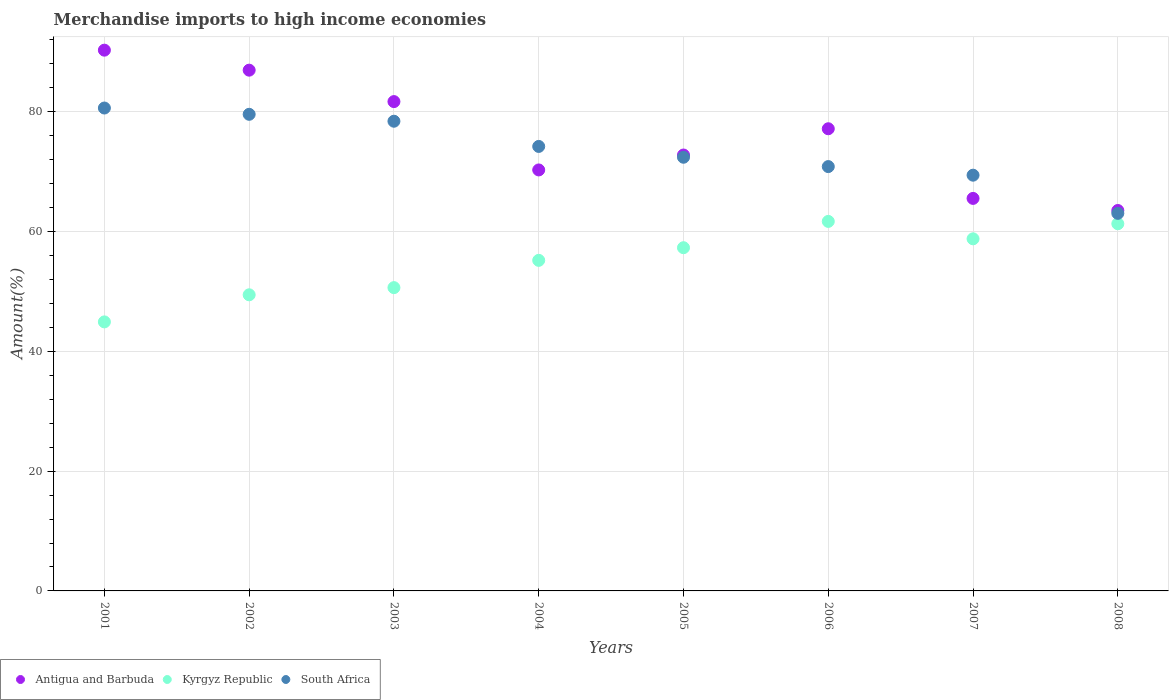What is the percentage of amount earned from merchandise imports in Kyrgyz Republic in 2001?
Keep it short and to the point. 44.92. Across all years, what is the maximum percentage of amount earned from merchandise imports in South Africa?
Make the answer very short. 80.63. Across all years, what is the minimum percentage of amount earned from merchandise imports in South Africa?
Provide a short and direct response. 63.05. In which year was the percentage of amount earned from merchandise imports in South Africa maximum?
Offer a terse response. 2001. What is the total percentage of amount earned from merchandise imports in Kyrgyz Republic in the graph?
Keep it short and to the point. 439.32. What is the difference between the percentage of amount earned from merchandise imports in South Africa in 2001 and that in 2007?
Your answer should be compact. 11.21. What is the difference between the percentage of amount earned from merchandise imports in Kyrgyz Republic in 2004 and the percentage of amount earned from merchandise imports in South Africa in 2003?
Keep it short and to the point. -23.23. What is the average percentage of amount earned from merchandise imports in Kyrgyz Republic per year?
Keep it short and to the point. 54.92. In the year 2003, what is the difference between the percentage of amount earned from merchandise imports in Kyrgyz Republic and percentage of amount earned from merchandise imports in Antigua and Barbuda?
Your answer should be very brief. -31.06. What is the ratio of the percentage of amount earned from merchandise imports in Kyrgyz Republic in 2003 to that in 2006?
Offer a very short reply. 0.82. Is the percentage of amount earned from merchandise imports in Kyrgyz Republic in 2002 less than that in 2003?
Provide a succinct answer. Yes. Is the difference between the percentage of amount earned from merchandise imports in Kyrgyz Republic in 2004 and 2008 greater than the difference between the percentage of amount earned from merchandise imports in Antigua and Barbuda in 2004 and 2008?
Provide a succinct answer. No. What is the difference between the highest and the second highest percentage of amount earned from merchandise imports in Antigua and Barbuda?
Your response must be concise. 3.34. What is the difference between the highest and the lowest percentage of amount earned from merchandise imports in Kyrgyz Republic?
Offer a very short reply. 16.78. Is the sum of the percentage of amount earned from merchandise imports in South Africa in 2002 and 2008 greater than the maximum percentage of amount earned from merchandise imports in Kyrgyz Republic across all years?
Give a very brief answer. Yes. Does the percentage of amount earned from merchandise imports in Antigua and Barbuda monotonically increase over the years?
Your response must be concise. No. How many dotlines are there?
Offer a very short reply. 3. What is the difference between two consecutive major ticks on the Y-axis?
Offer a terse response. 20. Are the values on the major ticks of Y-axis written in scientific E-notation?
Offer a very short reply. No. Does the graph contain any zero values?
Provide a short and direct response. No. How many legend labels are there?
Make the answer very short. 3. How are the legend labels stacked?
Ensure brevity in your answer.  Horizontal. What is the title of the graph?
Offer a terse response. Merchandise imports to high income economies. What is the label or title of the Y-axis?
Ensure brevity in your answer.  Amount(%). What is the Amount(%) of Antigua and Barbuda in 2001?
Your response must be concise. 90.29. What is the Amount(%) of Kyrgyz Republic in 2001?
Your answer should be compact. 44.92. What is the Amount(%) in South Africa in 2001?
Make the answer very short. 80.63. What is the Amount(%) of Antigua and Barbuda in 2002?
Provide a succinct answer. 86.95. What is the Amount(%) in Kyrgyz Republic in 2002?
Offer a very short reply. 49.44. What is the Amount(%) in South Africa in 2002?
Make the answer very short. 79.58. What is the Amount(%) of Antigua and Barbuda in 2003?
Ensure brevity in your answer.  81.71. What is the Amount(%) in Kyrgyz Republic in 2003?
Keep it short and to the point. 50.64. What is the Amount(%) in South Africa in 2003?
Keep it short and to the point. 78.43. What is the Amount(%) in Antigua and Barbuda in 2004?
Keep it short and to the point. 70.29. What is the Amount(%) of Kyrgyz Republic in 2004?
Offer a terse response. 55.2. What is the Amount(%) of South Africa in 2004?
Ensure brevity in your answer.  74.22. What is the Amount(%) of Antigua and Barbuda in 2005?
Ensure brevity in your answer.  72.79. What is the Amount(%) in Kyrgyz Republic in 2005?
Your answer should be compact. 57.31. What is the Amount(%) of South Africa in 2005?
Offer a terse response. 72.41. What is the Amount(%) in Antigua and Barbuda in 2006?
Your answer should be compact. 77.17. What is the Amount(%) of Kyrgyz Republic in 2006?
Your answer should be very brief. 61.7. What is the Amount(%) in South Africa in 2006?
Keep it short and to the point. 70.85. What is the Amount(%) in Antigua and Barbuda in 2007?
Give a very brief answer. 65.54. What is the Amount(%) in Kyrgyz Republic in 2007?
Provide a succinct answer. 58.79. What is the Amount(%) of South Africa in 2007?
Ensure brevity in your answer.  69.42. What is the Amount(%) of Antigua and Barbuda in 2008?
Offer a very short reply. 63.52. What is the Amount(%) in Kyrgyz Republic in 2008?
Your response must be concise. 61.31. What is the Amount(%) of South Africa in 2008?
Your answer should be compact. 63.05. Across all years, what is the maximum Amount(%) in Antigua and Barbuda?
Make the answer very short. 90.29. Across all years, what is the maximum Amount(%) of Kyrgyz Republic?
Your answer should be very brief. 61.7. Across all years, what is the maximum Amount(%) in South Africa?
Your answer should be compact. 80.63. Across all years, what is the minimum Amount(%) of Antigua and Barbuda?
Ensure brevity in your answer.  63.52. Across all years, what is the minimum Amount(%) of Kyrgyz Republic?
Your answer should be compact. 44.92. Across all years, what is the minimum Amount(%) in South Africa?
Make the answer very short. 63.05. What is the total Amount(%) of Antigua and Barbuda in the graph?
Your answer should be compact. 608.27. What is the total Amount(%) in Kyrgyz Republic in the graph?
Give a very brief answer. 439.32. What is the total Amount(%) in South Africa in the graph?
Provide a short and direct response. 588.6. What is the difference between the Amount(%) of Antigua and Barbuda in 2001 and that in 2002?
Make the answer very short. 3.34. What is the difference between the Amount(%) in Kyrgyz Republic in 2001 and that in 2002?
Offer a terse response. -4.52. What is the difference between the Amount(%) of South Africa in 2001 and that in 2002?
Give a very brief answer. 1.05. What is the difference between the Amount(%) of Antigua and Barbuda in 2001 and that in 2003?
Provide a succinct answer. 8.59. What is the difference between the Amount(%) of Kyrgyz Republic in 2001 and that in 2003?
Keep it short and to the point. -5.72. What is the difference between the Amount(%) of South Africa in 2001 and that in 2003?
Provide a succinct answer. 2.2. What is the difference between the Amount(%) in Antigua and Barbuda in 2001 and that in 2004?
Your response must be concise. 20. What is the difference between the Amount(%) of Kyrgyz Republic in 2001 and that in 2004?
Provide a short and direct response. -10.28. What is the difference between the Amount(%) in South Africa in 2001 and that in 2004?
Offer a terse response. 6.41. What is the difference between the Amount(%) of Antigua and Barbuda in 2001 and that in 2005?
Keep it short and to the point. 17.51. What is the difference between the Amount(%) in Kyrgyz Republic in 2001 and that in 2005?
Your answer should be compact. -12.39. What is the difference between the Amount(%) in South Africa in 2001 and that in 2005?
Make the answer very short. 8.22. What is the difference between the Amount(%) in Antigua and Barbuda in 2001 and that in 2006?
Offer a terse response. 13.12. What is the difference between the Amount(%) in Kyrgyz Republic in 2001 and that in 2006?
Provide a succinct answer. -16.78. What is the difference between the Amount(%) of South Africa in 2001 and that in 2006?
Your response must be concise. 9.78. What is the difference between the Amount(%) of Antigua and Barbuda in 2001 and that in 2007?
Your response must be concise. 24.75. What is the difference between the Amount(%) of Kyrgyz Republic in 2001 and that in 2007?
Give a very brief answer. -13.87. What is the difference between the Amount(%) of South Africa in 2001 and that in 2007?
Give a very brief answer. 11.21. What is the difference between the Amount(%) of Antigua and Barbuda in 2001 and that in 2008?
Give a very brief answer. 26.77. What is the difference between the Amount(%) in Kyrgyz Republic in 2001 and that in 2008?
Provide a succinct answer. -16.39. What is the difference between the Amount(%) in South Africa in 2001 and that in 2008?
Offer a terse response. 17.59. What is the difference between the Amount(%) of Antigua and Barbuda in 2002 and that in 2003?
Your answer should be very brief. 5.25. What is the difference between the Amount(%) of Kyrgyz Republic in 2002 and that in 2003?
Offer a very short reply. -1.2. What is the difference between the Amount(%) of South Africa in 2002 and that in 2003?
Provide a succinct answer. 1.16. What is the difference between the Amount(%) of Antigua and Barbuda in 2002 and that in 2004?
Your answer should be compact. 16.66. What is the difference between the Amount(%) in Kyrgyz Republic in 2002 and that in 2004?
Provide a succinct answer. -5.75. What is the difference between the Amount(%) in South Africa in 2002 and that in 2004?
Your answer should be compact. 5.36. What is the difference between the Amount(%) of Antigua and Barbuda in 2002 and that in 2005?
Your response must be concise. 14.17. What is the difference between the Amount(%) of Kyrgyz Republic in 2002 and that in 2005?
Your response must be concise. -7.86. What is the difference between the Amount(%) in South Africa in 2002 and that in 2005?
Make the answer very short. 7.17. What is the difference between the Amount(%) of Antigua and Barbuda in 2002 and that in 2006?
Make the answer very short. 9.78. What is the difference between the Amount(%) of Kyrgyz Republic in 2002 and that in 2006?
Make the answer very short. -12.26. What is the difference between the Amount(%) of South Africa in 2002 and that in 2006?
Your response must be concise. 8.73. What is the difference between the Amount(%) of Antigua and Barbuda in 2002 and that in 2007?
Offer a very short reply. 21.41. What is the difference between the Amount(%) in Kyrgyz Republic in 2002 and that in 2007?
Offer a terse response. -9.35. What is the difference between the Amount(%) in South Africa in 2002 and that in 2007?
Keep it short and to the point. 10.16. What is the difference between the Amount(%) of Antigua and Barbuda in 2002 and that in 2008?
Offer a terse response. 23.43. What is the difference between the Amount(%) in Kyrgyz Republic in 2002 and that in 2008?
Provide a short and direct response. -11.87. What is the difference between the Amount(%) of South Africa in 2002 and that in 2008?
Your answer should be compact. 16.54. What is the difference between the Amount(%) in Antigua and Barbuda in 2003 and that in 2004?
Give a very brief answer. 11.41. What is the difference between the Amount(%) in Kyrgyz Republic in 2003 and that in 2004?
Your answer should be very brief. -4.56. What is the difference between the Amount(%) in South Africa in 2003 and that in 2004?
Offer a terse response. 4.21. What is the difference between the Amount(%) of Antigua and Barbuda in 2003 and that in 2005?
Provide a short and direct response. 8.92. What is the difference between the Amount(%) in Kyrgyz Republic in 2003 and that in 2005?
Give a very brief answer. -6.67. What is the difference between the Amount(%) of South Africa in 2003 and that in 2005?
Keep it short and to the point. 6.01. What is the difference between the Amount(%) of Antigua and Barbuda in 2003 and that in 2006?
Provide a short and direct response. 4.54. What is the difference between the Amount(%) of Kyrgyz Republic in 2003 and that in 2006?
Your answer should be very brief. -11.06. What is the difference between the Amount(%) in South Africa in 2003 and that in 2006?
Your answer should be compact. 7.57. What is the difference between the Amount(%) in Antigua and Barbuda in 2003 and that in 2007?
Ensure brevity in your answer.  16.16. What is the difference between the Amount(%) in Kyrgyz Republic in 2003 and that in 2007?
Provide a succinct answer. -8.15. What is the difference between the Amount(%) in South Africa in 2003 and that in 2007?
Your answer should be compact. 9.01. What is the difference between the Amount(%) in Antigua and Barbuda in 2003 and that in 2008?
Offer a very short reply. 18.18. What is the difference between the Amount(%) in Kyrgyz Republic in 2003 and that in 2008?
Make the answer very short. -10.67. What is the difference between the Amount(%) of South Africa in 2003 and that in 2008?
Your answer should be very brief. 15.38. What is the difference between the Amount(%) in Antigua and Barbuda in 2004 and that in 2005?
Your answer should be very brief. -2.49. What is the difference between the Amount(%) of Kyrgyz Republic in 2004 and that in 2005?
Offer a very short reply. -2.11. What is the difference between the Amount(%) in South Africa in 2004 and that in 2005?
Offer a terse response. 1.81. What is the difference between the Amount(%) in Antigua and Barbuda in 2004 and that in 2006?
Your response must be concise. -6.88. What is the difference between the Amount(%) of Kyrgyz Republic in 2004 and that in 2006?
Keep it short and to the point. -6.5. What is the difference between the Amount(%) in South Africa in 2004 and that in 2006?
Your answer should be very brief. 3.36. What is the difference between the Amount(%) in Antigua and Barbuda in 2004 and that in 2007?
Ensure brevity in your answer.  4.75. What is the difference between the Amount(%) of Kyrgyz Republic in 2004 and that in 2007?
Ensure brevity in your answer.  -3.6. What is the difference between the Amount(%) of South Africa in 2004 and that in 2007?
Your answer should be compact. 4.8. What is the difference between the Amount(%) of Antigua and Barbuda in 2004 and that in 2008?
Your answer should be very brief. 6.77. What is the difference between the Amount(%) in Kyrgyz Republic in 2004 and that in 2008?
Your answer should be very brief. -6.11. What is the difference between the Amount(%) of South Africa in 2004 and that in 2008?
Provide a short and direct response. 11.17. What is the difference between the Amount(%) in Antigua and Barbuda in 2005 and that in 2006?
Your answer should be very brief. -4.38. What is the difference between the Amount(%) of Kyrgyz Republic in 2005 and that in 2006?
Ensure brevity in your answer.  -4.39. What is the difference between the Amount(%) of South Africa in 2005 and that in 2006?
Your response must be concise. 1.56. What is the difference between the Amount(%) in Antigua and Barbuda in 2005 and that in 2007?
Offer a very short reply. 7.24. What is the difference between the Amount(%) in Kyrgyz Republic in 2005 and that in 2007?
Your answer should be compact. -1.49. What is the difference between the Amount(%) in South Africa in 2005 and that in 2007?
Give a very brief answer. 2.99. What is the difference between the Amount(%) in Antigua and Barbuda in 2005 and that in 2008?
Provide a succinct answer. 9.26. What is the difference between the Amount(%) of Kyrgyz Republic in 2005 and that in 2008?
Your response must be concise. -4. What is the difference between the Amount(%) of South Africa in 2005 and that in 2008?
Keep it short and to the point. 9.37. What is the difference between the Amount(%) in Antigua and Barbuda in 2006 and that in 2007?
Your answer should be very brief. 11.63. What is the difference between the Amount(%) in Kyrgyz Republic in 2006 and that in 2007?
Make the answer very short. 2.91. What is the difference between the Amount(%) in South Africa in 2006 and that in 2007?
Your answer should be compact. 1.44. What is the difference between the Amount(%) of Antigua and Barbuda in 2006 and that in 2008?
Offer a terse response. 13.65. What is the difference between the Amount(%) in Kyrgyz Republic in 2006 and that in 2008?
Make the answer very short. 0.39. What is the difference between the Amount(%) of South Africa in 2006 and that in 2008?
Offer a terse response. 7.81. What is the difference between the Amount(%) in Antigua and Barbuda in 2007 and that in 2008?
Your answer should be compact. 2.02. What is the difference between the Amount(%) in Kyrgyz Republic in 2007 and that in 2008?
Your response must be concise. -2.52. What is the difference between the Amount(%) in South Africa in 2007 and that in 2008?
Keep it short and to the point. 6.37. What is the difference between the Amount(%) of Antigua and Barbuda in 2001 and the Amount(%) of Kyrgyz Republic in 2002?
Keep it short and to the point. 40.85. What is the difference between the Amount(%) of Antigua and Barbuda in 2001 and the Amount(%) of South Africa in 2002?
Give a very brief answer. 10.71. What is the difference between the Amount(%) in Kyrgyz Republic in 2001 and the Amount(%) in South Africa in 2002?
Your answer should be very brief. -34.66. What is the difference between the Amount(%) of Antigua and Barbuda in 2001 and the Amount(%) of Kyrgyz Republic in 2003?
Ensure brevity in your answer.  39.65. What is the difference between the Amount(%) in Antigua and Barbuda in 2001 and the Amount(%) in South Africa in 2003?
Your response must be concise. 11.87. What is the difference between the Amount(%) of Kyrgyz Republic in 2001 and the Amount(%) of South Africa in 2003?
Your response must be concise. -33.51. What is the difference between the Amount(%) in Antigua and Barbuda in 2001 and the Amount(%) in Kyrgyz Republic in 2004?
Your answer should be compact. 35.1. What is the difference between the Amount(%) of Antigua and Barbuda in 2001 and the Amount(%) of South Africa in 2004?
Provide a short and direct response. 16.08. What is the difference between the Amount(%) of Kyrgyz Republic in 2001 and the Amount(%) of South Africa in 2004?
Offer a terse response. -29.3. What is the difference between the Amount(%) in Antigua and Barbuda in 2001 and the Amount(%) in Kyrgyz Republic in 2005?
Ensure brevity in your answer.  32.99. What is the difference between the Amount(%) in Antigua and Barbuda in 2001 and the Amount(%) in South Africa in 2005?
Provide a succinct answer. 17.88. What is the difference between the Amount(%) in Kyrgyz Republic in 2001 and the Amount(%) in South Africa in 2005?
Your response must be concise. -27.49. What is the difference between the Amount(%) of Antigua and Barbuda in 2001 and the Amount(%) of Kyrgyz Republic in 2006?
Your answer should be compact. 28.59. What is the difference between the Amount(%) in Antigua and Barbuda in 2001 and the Amount(%) in South Africa in 2006?
Provide a short and direct response. 19.44. What is the difference between the Amount(%) in Kyrgyz Republic in 2001 and the Amount(%) in South Africa in 2006?
Provide a succinct answer. -25.93. What is the difference between the Amount(%) in Antigua and Barbuda in 2001 and the Amount(%) in Kyrgyz Republic in 2007?
Ensure brevity in your answer.  31.5. What is the difference between the Amount(%) in Antigua and Barbuda in 2001 and the Amount(%) in South Africa in 2007?
Provide a short and direct response. 20.88. What is the difference between the Amount(%) in Kyrgyz Republic in 2001 and the Amount(%) in South Africa in 2007?
Your answer should be compact. -24.5. What is the difference between the Amount(%) of Antigua and Barbuda in 2001 and the Amount(%) of Kyrgyz Republic in 2008?
Give a very brief answer. 28.98. What is the difference between the Amount(%) in Antigua and Barbuda in 2001 and the Amount(%) in South Africa in 2008?
Your answer should be compact. 27.25. What is the difference between the Amount(%) of Kyrgyz Republic in 2001 and the Amount(%) of South Africa in 2008?
Your answer should be very brief. -18.12. What is the difference between the Amount(%) of Antigua and Barbuda in 2002 and the Amount(%) of Kyrgyz Republic in 2003?
Your response must be concise. 36.31. What is the difference between the Amount(%) in Antigua and Barbuda in 2002 and the Amount(%) in South Africa in 2003?
Ensure brevity in your answer.  8.53. What is the difference between the Amount(%) of Kyrgyz Republic in 2002 and the Amount(%) of South Africa in 2003?
Keep it short and to the point. -28.98. What is the difference between the Amount(%) in Antigua and Barbuda in 2002 and the Amount(%) in Kyrgyz Republic in 2004?
Provide a succinct answer. 31.76. What is the difference between the Amount(%) of Antigua and Barbuda in 2002 and the Amount(%) of South Africa in 2004?
Provide a succinct answer. 12.73. What is the difference between the Amount(%) of Kyrgyz Republic in 2002 and the Amount(%) of South Africa in 2004?
Your answer should be compact. -24.77. What is the difference between the Amount(%) in Antigua and Barbuda in 2002 and the Amount(%) in Kyrgyz Republic in 2005?
Provide a short and direct response. 29.65. What is the difference between the Amount(%) in Antigua and Barbuda in 2002 and the Amount(%) in South Africa in 2005?
Your response must be concise. 14.54. What is the difference between the Amount(%) of Kyrgyz Republic in 2002 and the Amount(%) of South Africa in 2005?
Provide a short and direct response. -22.97. What is the difference between the Amount(%) in Antigua and Barbuda in 2002 and the Amount(%) in Kyrgyz Republic in 2006?
Provide a short and direct response. 25.25. What is the difference between the Amount(%) in Antigua and Barbuda in 2002 and the Amount(%) in South Africa in 2006?
Your response must be concise. 16.1. What is the difference between the Amount(%) of Kyrgyz Republic in 2002 and the Amount(%) of South Africa in 2006?
Offer a very short reply. -21.41. What is the difference between the Amount(%) of Antigua and Barbuda in 2002 and the Amount(%) of Kyrgyz Republic in 2007?
Offer a very short reply. 28.16. What is the difference between the Amount(%) of Antigua and Barbuda in 2002 and the Amount(%) of South Africa in 2007?
Provide a succinct answer. 17.54. What is the difference between the Amount(%) of Kyrgyz Republic in 2002 and the Amount(%) of South Africa in 2007?
Offer a terse response. -19.97. What is the difference between the Amount(%) in Antigua and Barbuda in 2002 and the Amount(%) in Kyrgyz Republic in 2008?
Keep it short and to the point. 25.64. What is the difference between the Amount(%) in Antigua and Barbuda in 2002 and the Amount(%) in South Africa in 2008?
Offer a terse response. 23.91. What is the difference between the Amount(%) of Kyrgyz Republic in 2002 and the Amount(%) of South Africa in 2008?
Your response must be concise. -13.6. What is the difference between the Amount(%) of Antigua and Barbuda in 2003 and the Amount(%) of Kyrgyz Republic in 2004?
Your answer should be compact. 26.51. What is the difference between the Amount(%) of Antigua and Barbuda in 2003 and the Amount(%) of South Africa in 2004?
Provide a succinct answer. 7.49. What is the difference between the Amount(%) in Kyrgyz Republic in 2003 and the Amount(%) in South Africa in 2004?
Your answer should be very brief. -23.58. What is the difference between the Amount(%) of Antigua and Barbuda in 2003 and the Amount(%) of Kyrgyz Republic in 2005?
Make the answer very short. 24.4. What is the difference between the Amount(%) in Antigua and Barbuda in 2003 and the Amount(%) in South Africa in 2005?
Offer a very short reply. 9.29. What is the difference between the Amount(%) of Kyrgyz Republic in 2003 and the Amount(%) of South Africa in 2005?
Your response must be concise. -21.77. What is the difference between the Amount(%) in Antigua and Barbuda in 2003 and the Amount(%) in Kyrgyz Republic in 2006?
Offer a very short reply. 20.01. What is the difference between the Amount(%) in Antigua and Barbuda in 2003 and the Amount(%) in South Africa in 2006?
Your response must be concise. 10.85. What is the difference between the Amount(%) of Kyrgyz Republic in 2003 and the Amount(%) of South Africa in 2006?
Your response must be concise. -20.21. What is the difference between the Amount(%) in Antigua and Barbuda in 2003 and the Amount(%) in Kyrgyz Republic in 2007?
Ensure brevity in your answer.  22.91. What is the difference between the Amount(%) in Antigua and Barbuda in 2003 and the Amount(%) in South Africa in 2007?
Give a very brief answer. 12.29. What is the difference between the Amount(%) of Kyrgyz Republic in 2003 and the Amount(%) of South Africa in 2007?
Provide a short and direct response. -18.78. What is the difference between the Amount(%) of Antigua and Barbuda in 2003 and the Amount(%) of Kyrgyz Republic in 2008?
Give a very brief answer. 20.39. What is the difference between the Amount(%) in Antigua and Barbuda in 2003 and the Amount(%) in South Africa in 2008?
Keep it short and to the point. 18.66. What is the difference between the Amount(%) in Kyrgyz Republic in 2003 and the Amount(%) in South Africa in 2008?
Give a very brief answer. -12.4. What is the difference between the Amount(%) in Antigua and Barbuda in 2004 and the Amount(%) in Kyrgyz Republic in 2005?
Offer a terse response. 12.99. What is the difference between the Amount(%) of Antigua and Barbuda in 2004 and the Amount(%) of South Africa in 2005?
Ensure brevity in your answer.  -2.12. What is the difference between the Amount(%) of Kyrgyz Republic in 2004 and the Amount(%) of South Africa in 2005?
Provide a short and direct response. -17.21. What is the difference between the Amount(%) of Antigua and Barbuda in 2004 and the Amount(%) of Kyrgyz Republic in 2006?
Keep it short and to the point. 8.59. What is the difference between the Amount(%) of Antigua and Barbuda in 2004 and the Amount(%) of South Africa in 2006?
Your answer should be very brief. -0.56. What is the difference between the Amount(%) in Kyrgyz Republic in 2004 and the Amount(%) in South Africa in 2006?
Offer a very short reply. -15.66. What is the difference between the Amount(%) of Antigua and Barbuda in 2004 and the Amount(%) of Kyrgyz Republic in 2007?
Offer a terse response. 11.5. What is the difference between the Amount(%) in Antigua and Barbuda in 2004 and the Amount(%) in South Africa in 2007?
Your answer should be compact. 0.88. What is the difference between the Amount(%) in Kyrgyz Republic in 2004 and the Amount(%) in South Africa in 2007?
Your answer should be compact. -14.22. What is the difference between the Amount(%) in Antigua and Barbuda in 2004 and the Amount(%) in Kyrgyz Republic in 2008?
Offer a very short reply. 8.98. What is the difference between the Amount(%) of Antigua and Barbuda in 2004 and the Amount(%) of South Africa in 2008?
Keep it short and to the point. 7.25. What is the difference between the Amount(%) in Kyrgyz Republic in 2004 and the Amount(%) in South Africa in 2008?
Offer a terse response. -7.85. What is the difference between the Amount(%) of Antigua and Barbuda in 2005 and the Amount(%) of Kyrgyz Republic in 2006?
Offer a very short reply. 11.08. What is the difference between the Amount(%) in Antigua and Barbuda in 2005 and the Amount(%) in South Africa in 2006?
Ensure brevity in your answer.  1.93. What is the difference between the Amount(%) in Kyrgyz Republic in 2005 and the Amount(%) in South Africa in 2006?
Offer a very short reply. -13.55. What is the difference between the Amount(%) in Antigua and Barbuda in 2005 and the Amount(%) in Kyrgyz Republic in 2007?
Give a very brief answer. 13.99. What is the difference between the Amount(%) of Antigua and Barbuda in 2005 and the Amount(%) of South Africa in 2007?
Provide a short and direct response. 3.37. What is the difference between the Amount(%) in Kyrgyz Republic in 2005 and the Amount(%) in South Africa in 2007?
Your answer should be compact. -12.11. What is the difference between the Amount(%) in Antigua and Barbuda in 2005 and the Amount(%) in Kyrgyz Republic in 2008?
Your answer should be compact. 11.47. What is the difference between the Amount(%) in Antigua and Barbuda in 2005 and the Amount(%) in South Africa in 2008?
Make the answer very short. 9.74. What is the difference between the Amount(%) of Kyrgyz Republic in 2005 and the Amount(%) of South Africa in 2008?
Provide a short and direct response. -5.74. What is the difference between the Amount(%) of Antigua and Barbuda in 2006 and the Amount(%) of Kyrgyz Republic in 2007?
Ensure brevity in your answer.  18.38. What is the difference between the Amount(%) of Antigua and Barbuda in 2006 and the Amount(%) of South Africa in 2007?
Your answer should be very brief. 7.75. What is the difference between the Amount(%) of Kyrgyz Republic in 2006 and the Amount(%) of South Africa in 2007?
Your answer should be very brief. -7.72. What is the difference between the Amount(%) of Antigua and Barbuda in 2006 and the Amount(%) of Kyrgyz Republic in 2008?
Your answer should be very brief. 15.86. What is the difference between the Amount(%) in Antigua and Barbuda in 2006 and the Amount(%) in South Africa in 2008?
Make the answer very short. 14.12. What is the difference between the Amount(%) in Kyrgyz Republic in 2006 and the Amount(%) in South Africa in 2008?
Your answer should be compact. -1.35. What is the difference between the Amount(%) in Antigua and Barbuda in 2007 and the Amount(%) in Kyrgyz Republic in 2008?
Offer a terse response. 4.23. What is the difference between the Amount(%) in Antigua and Barbuda in 2007 and the Amount(%) in South Africa in 2008?
Make the answer very short. 2.5. What is the difference between the Amount(%) of Kyrgyz Republic in 2007 and the Amount(%) of South Africa in 2008?
Provide a short and direct response. -4.25. What is the average Amount(%) of Antigua and Barbuda per year?
Your answer should be compact. 76.03. What is the average Amount(%) of Kyrgyz Republic per year?
Keep it short and to the point. 54.92. What is the average Amount(%) in South Africa per year?
Make the answer very short. 73.57. In the year 2001, what is the difference between the Amount(%) of Antigua and Barbuda and Amount(%) of Kyrgyz Republic?
Keep it short and to the point. 45.37. In the year 2001, what is the difference between the Amount(%) of Antigua and Barbuda and Amount(%) of South Africa?
Make the answer very short. 9.66. In the year 2001, what is the difference between the Amount(%) in Kyrgyz Republic and Amount(%) in South Africa?
Provide a short and direct response. -35.71. In the year 2002, what is the difference between the Amount(%) in Antigua and Barbuda and Amount(%) in Kyrgyz Republic?
Your response must be concise. 37.51. In the year 2002, what is the difference between the Amount(%) of Antigua and Barbuda and Amount(%) of South Africa?
Ensure brevity in your answer.  7.37. In the year 2002, what is the difference between the Amount(%) of Kyrgyz Republic and Amount(%) of South Africa?
Your answer should be very brief. -30.14. In the year 2003, what is the difference between the Amount(%) of Antigua and Barbuda and Amount(%) of Kyrgyz Republic?
Provide a succinct answer. 31.06. In the year 2003, what is the difference between the Amount(%) of Antigua and Barbuda and Amount(%) of South Africa?
Offer a very short reply. 3.28. In the year 2003, what is the difference between the Amount(%) of Kyrgyz Republic and Amount(%) of South Africa?
Provide a succinct answer. -27.79. In the year 2004, what is the difference between the Amount(%) in Antigua and Barbuda and Amount(%) in Kyrgyz Republic?
Offer a very short reply. 15.1. In the year 2004, what is the difference between the Amount(%) in Antigua and Barbuda and Amount(%) in South Africa?
Give a very brief answer. -3.92. In the year 2004, what is the difference between the Amount(%) of Kyrgyz Republic and Amount(%) of South Africa?
Your answer should be compact. -19.02. In the year 2005, what is the difference between the Amount(%) in Antigua and Barbuda and Amount(%) in Kyrgyz Republic?
Offer a very short reply. 15.48. In the year 2005, what is the difference between the Amount(%) in Antigua and Barbuda and Amount(%) in South Africa?
Your answer should be very brief. 0.37. In the year 2005, what is the difference between the Amount(%) of Kyrgyz Republic and Amount(%) of South Africa?
Provide a succinct answer. -15.11. In the year 2006, what is the difference between the Amount(%) in Antigua and Barbuda and Amount(%) in Kyrgyz Republic?
Offer a terse response. 15.47. In the year 2006, what is the difference between the Amount(%) of Antigua and Barbuda and Amount(%) of South Africa?
Provide a short and direct response. 6.32. In the year 2006, what is the difference between the Amount(%) of Kyrgyz Republic and Amount(%) of South Africa?
Ensure brevity in your answer.  -9.15. In the year 2007, what is the difference between the Amount(%) of Antigua and Barbuda and Amount(%) of Kyrgyz Republic?
Your answer should be compact. 6.75. In the year 2007, what is the difference between the Amount(%) in Antigua and Barbuda and Amount(%) in South Africa?
Keep it short and to the point. -3.88. In the year 2007, what is the difference between the Amount(%) of Kyrgyz Republic and Amount(%) of South Africa?
Give a very brief answer. -10.63. In the year 2008, what is the difference between the Amount(%) in Antigua and Barbuda and Amount(%) in Kyrgyz Republic?
Your response must be concise. 2.21. In the year 2008, what is the difference between the Amount(%) in Antigua and Barbuda and Amount(%) in South Africa?
Your answer should be very brief. 0.48. In the year 2008, what is the difference between the Amount(%) in Kyrgyz Republic and Amount(%) in South Africa?
Keep it short and to the point. -1.73. What is the ratio of the Amount(%) in Antigua and Barbuda in 2001 to that in 2002?
Provide a short and direct response. 1.04. What is the ratio of the Amount(%) in Kyrgyz Republic in 2001 to that in 2002?
Make the answer very short. 0.91. What is the ratio of the Amount(%) in South Africa in 2001 to that in 2002?
Your answer should be very brief. 1.01. What is the ratio of the Amount(%) in Antigua and Barbuda in 2001 to that in 2003?
Keep it short and to the point. 1.11. What is the ratio of the Amount(%) in Kyrgyz Republic in 2001 to that in 2003?
Your answer should be compact. 0.89. What is the ratio of the Amount(%) of South Africa in 2001 to that in 2003?
Offer a very short reply. 1.03. What is the ratio of the Amount(%) of Antigua and Barbuda in 2001 to that in 2004?
Your answer should be very brief. 1.28. What is the ratio of the Amount(%) in Kyrgyz Republic in 2001 to that in 2004?
Offer a terse response. 0.81. What is the ratio of the Amount(%) of South Africa in 2001 to that in 2004?
Make the answer very short. 1.09. What is the ratio of the Amount(%) of Antigua and Barbuda in 2001 to that in 2005?
Keep it short and to the point. 1.24. What is the ratio of the Amount(%) of Kyrgyz Republic in 2001 to that in 2005?
Your answer should be very brief. 0.78. What is the ratio of the Amount(%) in South Africa in 2001 to that in 2005?
Your answer should be very brief. 1.11. What is the ratio of the Amount(%) of Antigua and Barbuda in 2001 to that in 2006?
Keep it short and to the point. 1.17. What is the ratio of the Amount(%) in Kyrgyz Republic in 2001 to that in 2006?
Provide a succinct answer. 0.73. What is the ratio of the Amount(%) of South Africa in 2001 to that in 2006?
Provide a succinct answer. 1.14. What is the ratio of the Amount(%) of Antigua and Barbuda in 2001 to that in 2007?
Make the answer very short. 1.38. What is the ratio of the Amount(%) of Kyrgyz Republic in 2001 to that in 2007?
Provide a short and direct response. 0.76. What is the ratio of the Amount(%) in South Africa in 2001 to that in 2007?
Keep it short and to the point. 1.16. What is the ratio of the Amount(%) of Antigua and Barbuda in 2001 to that in 2008?
Keep it short and to the point. 1.42. What is the ratio of the Amount(%) in Kyrgyz Republic in 2001 to that in 2008?
Provide a succinct answer. 0.73. What is the ratio of the Amount(%) of South Africa in 2001 to that in 2008?
Provide a short and direct response. 1.28. What is the ratio of the Amount(%) of Antigua and Barbuda in 2002 to that in 2003?
Your answer should be very brief. 1.06. What is the ratio of the Amount(%) of Kyrgyz Republic in 2002 to that in 2003?
Your response must be concise. 0.98. What is the ratio of the Amount(%) in South Africa in 2002 to that in 2003?
Provide a succinct answer. 1.01. What is the ratio of the Amount(%) in Antigua and Barbuda in 2002 to that in 2004?
Offer a terse response. 1.24. What is the ratio of the Amount(%) of Kyrgyz Republic in 2002 to that in 2004?
Ensure brevity in your answer.  0.9. What is the ratio of the Amount(%) of South Africa in 2002 to that in 2004?
Provide a succinct answer. 1.07. What is the ratio of the Amount(%) of Antigua and Barbuda in 2002 to that in 2005?
Your answer should be compact. 1.19. What is the ratio of the Amount(%) of Kyrgyz Republic in 2002 to that in 2005?
Your answer should be very brief. 0.86. What is the ratio of the Amount(%) of South Africa in 2002 to that in 2005?
Provide a short and direct response. 1.1. What is the ratio of the Amount(%) of Antigua and Barbuda in 2002 to that in 2006?
Make the answer very short. 1.13. What is the ratio of the Amount(%) of Kyrgyz Republic in 2002 to that in 2006?
Offer a terse response. 0.8. What is the ratio of the Amount(%) of South Africa in 2002 to that in 2006?
Offer a very short reply. 1.12. What is the ratio of the Amount(%) in Antigua and Barbuda in 2002 to that in 2007?
Make the answer very short. 1.33. What is the ratio of the Amount(%) of Kyrgyz Republic in 2002 to that in 2007?
Provide a short and direct response. 0.84. What is the ratio of the Amount(%) of South Africa in 2002 to that in 2007?
Your answer should be very brief. 1.15. What is the ratio of the Amount(%) in Antigua and Barbuda in 2002 to that in 2008?
Your answer should be compact. 1.37. What is the ratio of the Amount(%) of Kyrgyz Republic in 2002 to that in 2008?
Keep it short and to the point. 0.81. What is the ratio of the Amount(%) in South Africa in 2002 to that in 2008?
Make the answer very short. 1.26. What is the ratio of the Amount(%) of Antigua and Barbuda in 2003 to that in 2004?
Offer a very short reply. 1.16. What is the ratio of the Amount(%) of Kyrgyz Republic in 2003 to that in 2004?
Provide a short and direct response. 0.92. What is the ratio of the Amount(%) of South Africa in 2003 to that in 2004?
Keep it short and to the point. 1.06. What is the ratio of the Amount(%) in Antigua and Barbuda in 2003 to that in 2005?
Make the answer very short. 1.12. What is the ratio of the Amount(%) of Kyrgyz Republic in 2003 to that in 2005?
Offer a terse response. 0.88. What is the ratio of the Amount(%) of South Africa in 2003 to that in 2005?
Keep it short and to the point. 1.08. What is the ratio of the Amount(%) in Antigua and Barbuda in 2003 to that in 2006?
Provide a succinct answer. 1.06. What is the ratio of the Amount(%) of Kyrgyz Republic in 2003 to that in 2006?
Give a very brief answer. 0.82. What is the ratio of the Amount(%) of South Africa in 2003 to that in 2006?
Keep it short and to the point. 1.11. What is the ratio of the Amount(%) of Antigua and Barbuda in 2003 to that in 2007?
Offer a very short reply. 1.25. What is the ratio of the Amount(%) of Kyrgyz Republic in 2003 to that in 2007?
Provide a short and direct response. 0.86. What is the ratio of the Amount(%) in South Africa in 2003 to that in 2007?
Your answer should be compact. 1.13. What is the ratio of the Amount(%) of Antigua and Barbuda in 2003 to that in 2008?
Provide a short and direct response. 1.29. What is the ratio of the Amount(%) of Kyrgyz Republic in 2003 to that in 2008?
Provide a succinct answer. 0.83. What is the ratio of the Amount(%) of South Africa in 2003 to that in 2008?
Provide a short and direct response. 1.24. What is the ratio of the Amount(%) in Antigua and Barbuda in 2004 to that in 2005?
Offer a very short reply. 0.97. What is the ratio of the Amount(%) of Kyrgyz Republic in 2004 to that in 2005?
Your answer should be very brief. 0.96. What is the ratio of the Amount(%) in South Africa in 2004 to that in 2005?
Provide a succinct answer. 1.02. What is the ratio of the Amount(%) of Antigua and Barbuda in 2004 to that in 2006?
Ensure brevity in your answer.  0.91. What is the ratio of the Amount(%) of Kyrgyz Republic in 2004 to that in 2006?
Provide a succinct answer. 0.89. What is the ratio of the Amount(%) of South Africa in 2004 to that in 2006?
Your answer should be compact. 1.05. What is the ratio of the Amount(%) in Antigua and Barbuda in 2004 to that in 2007?
Your answer should be compact. 1.07. What is the ratio of the Amount(%) of Kyrgyz Republic in 2004 to that in 2007?
Provide a succinct answer. 0.94. What is the ratio of the Amount(%) in South Africa in 2004 to that in 2007?
Keep it short and to the point. 1.07. What is the ratio of the Amount(%) of Antigua and Barbuda in 2004 to that in 2008?
Offer a very short reply. 1.11. What is the ratio of the Amount(%) of Kyrgyz Republic in 2004 to that in 2008?
Offer a very short reply. 0.9. What is the ratio of the Amount(%) in South Africa in 2004 to that in 2008?
Offer a terse response. 1.18. What is the ratio of the Amount(%) of Antigua and Barbuda in 2005 to that in 2006?
Your response must be concise. 0.94. What is the ratio of the Amount(%) of Kyrgyz Republic in 2005 to that in 2006?
Make the answer very short. 0.93. What is the ratio of the Amount(%) of Antigua and Barbuda in 2005 to that in 2007?
Your response must be concise. 1.11. What is the ratio of the Amount(%) of Kyrgyz Republic in 2005 to that in 2007?
Your answer should be compact. 0.97. What is the ratio of the Amount(%) of South Africa in 2005 to that in 2007?
Your response must be concise. 1.04. What is the ratio of the Amount(%) of Antigua and Barbuda in 2005 to that in 2008?
Give a very brief answer. 1.15. What is the ratio of the Amount(%) in Kyrgyz Republic in 2005 to that in 2008?
Offer a terse response. 0.93. What is the ratio of the Amount(%) in South Africa in 2005 to that in 2008?
Ensure brevity in your answer.  1.15. What is the ratio of the Amount(%) of Antigua and Barbuda in 2006 to that in 2007?
Give a very brief answer. 1.18. What is the ratio of the Amount(%) of Kyrgyz Republic in 2006 to that in 2007?
Provide a short and direct response. 1.05. What is the ratio of the Amount(%) in South Africa in 2006 to that in 2007?
Ensure brevity in your answer.  1.02. What is the ratio of the Amount(%) in Antigua and Barbuda in 2006 to that in 2008?
Provide a short and direct response. 1.21. What is the ratio of the Amount(%) in Kyrgyz Republic in 2006 to that in 2008?
Provide a short and direct response. 1.01. What is the ratio of the Amount(%) of South Africa in 2006 to that in 2008?
Provide a succinct answer. 1.12. What is the ratio of the Amount(%) of Antigua and Barbuda in 2007 to that in 2008?
Your answer should be compact. 1.03. What is the ratio of the Amount(%) of Kyrgyz Republic in 2007 to that in 2008?
Your answer should be compact. 0.96. What is the ratio of the Amount(%) in South Africa in 2007 to that in 2008?
Your answer should be very brief. 1.1. What is the difference between the highest and the second highest Amount(%) of Antigua and Barbuda?
Keep it short and to the point. 3.34. What is the difference between the highest and the second highest Amount(%) of Kyrgyz Republic?
Make the answer very short. 0.39. What is the difference between the highest and the second highest Amount(%) in South Africa?
Ensure brevity in your answer.  1.05. What is the difference between the highest and the lowest Amount(%) of Antigua and Barbuda?
Your answer should be compact. 26.77. What is the difference between the highest and the lowest Amount(%) in Kyrgyz Republic?
Give a very brief answer. 16.78. What is the difference between the highest and the lowest Amount(%) in South Africa?
Ensure brevity in your answer.  17.59. 